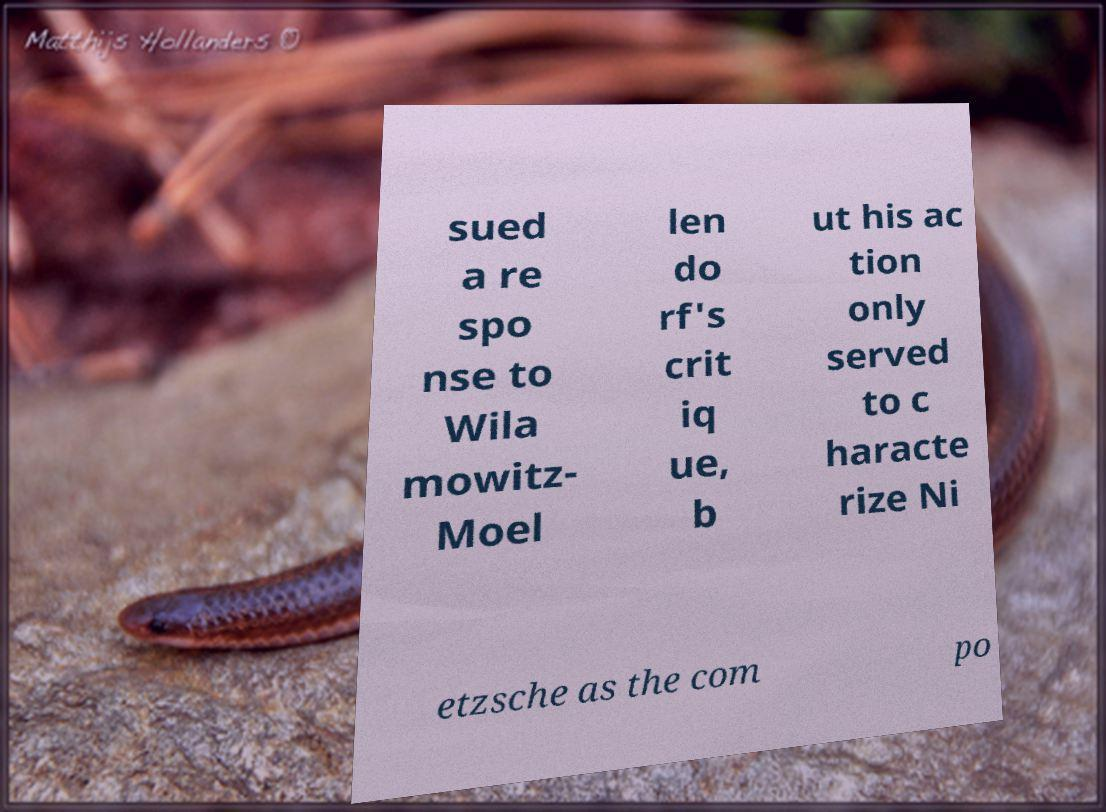Can you read and provide the text displayed in the image?This photo seems to have some interesting text. Can you extract and type it out for me? sued a re spo nse to Wila mowitz- Moel len do rf's crit iq ue, b ut his ac tion only served to c haracte rize Ni etzsche as the com po 